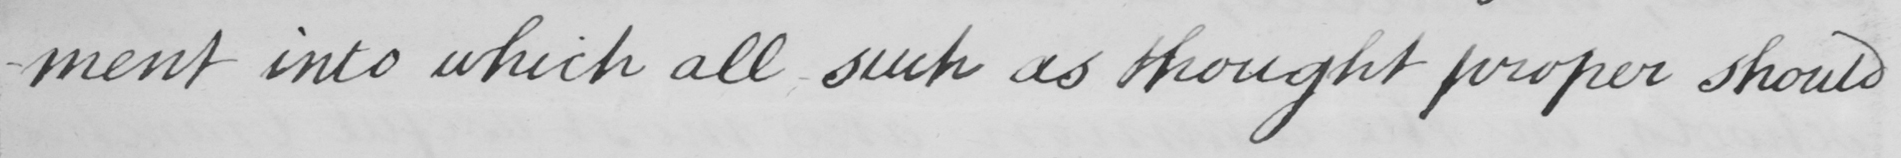Please provide the text content of this handwritten line. -ment into which all such as though proper should 